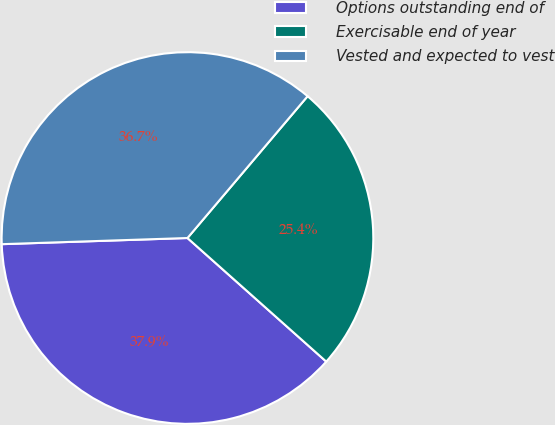Convert chart to OTSL. <chart><loc_0><loc_0><loc_500><loc_500><pie_chart><fcel>Options outstanding end of<fcel>Exercisable end of year<fcel>Vested and expected to vest<nl><fcel>37.89%<fcel>25.39%<fcel>36.71%<nl></chart> 